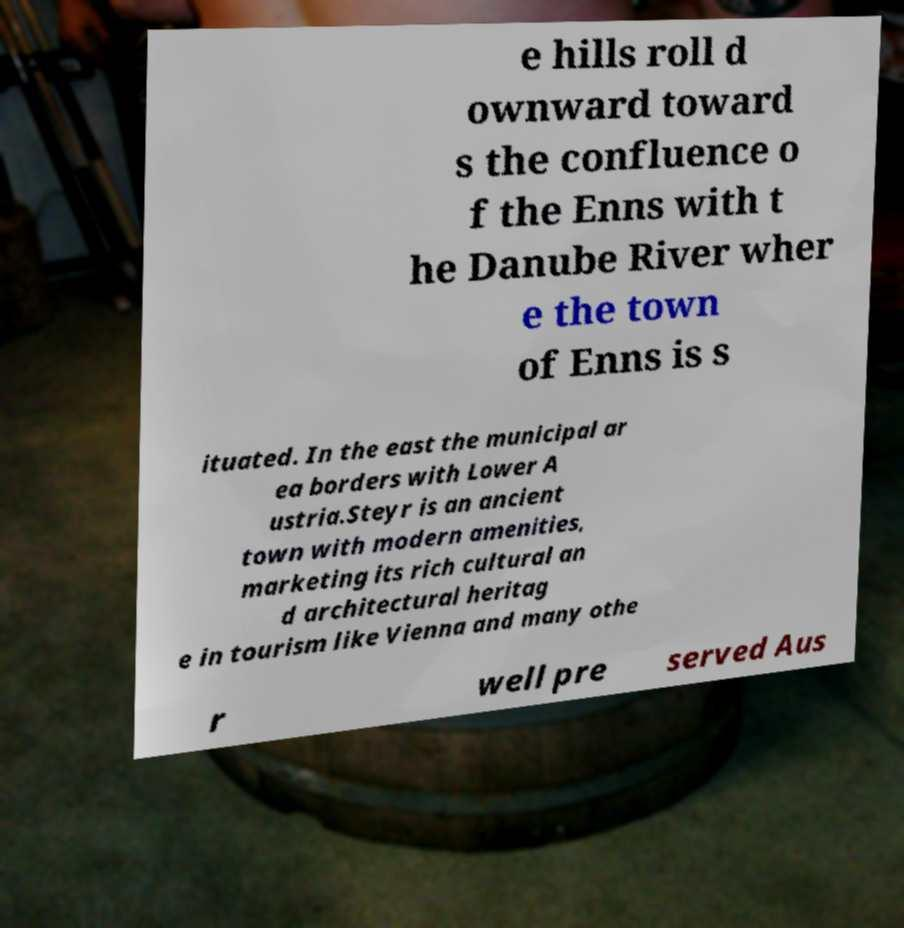Please identify and transcribe the text found in this image. e hills roll d ownward toward s the confluence o f the Enns with t he Danube River wher e the town of Enns is s ituated. In the east the municipal ar ea borders with Lower A ustria.Steyr is an ancient town with modern amenities, marketing its rich cultural an d architectural heritag e in tourism like Vienna and many othe r well pre served Aus 